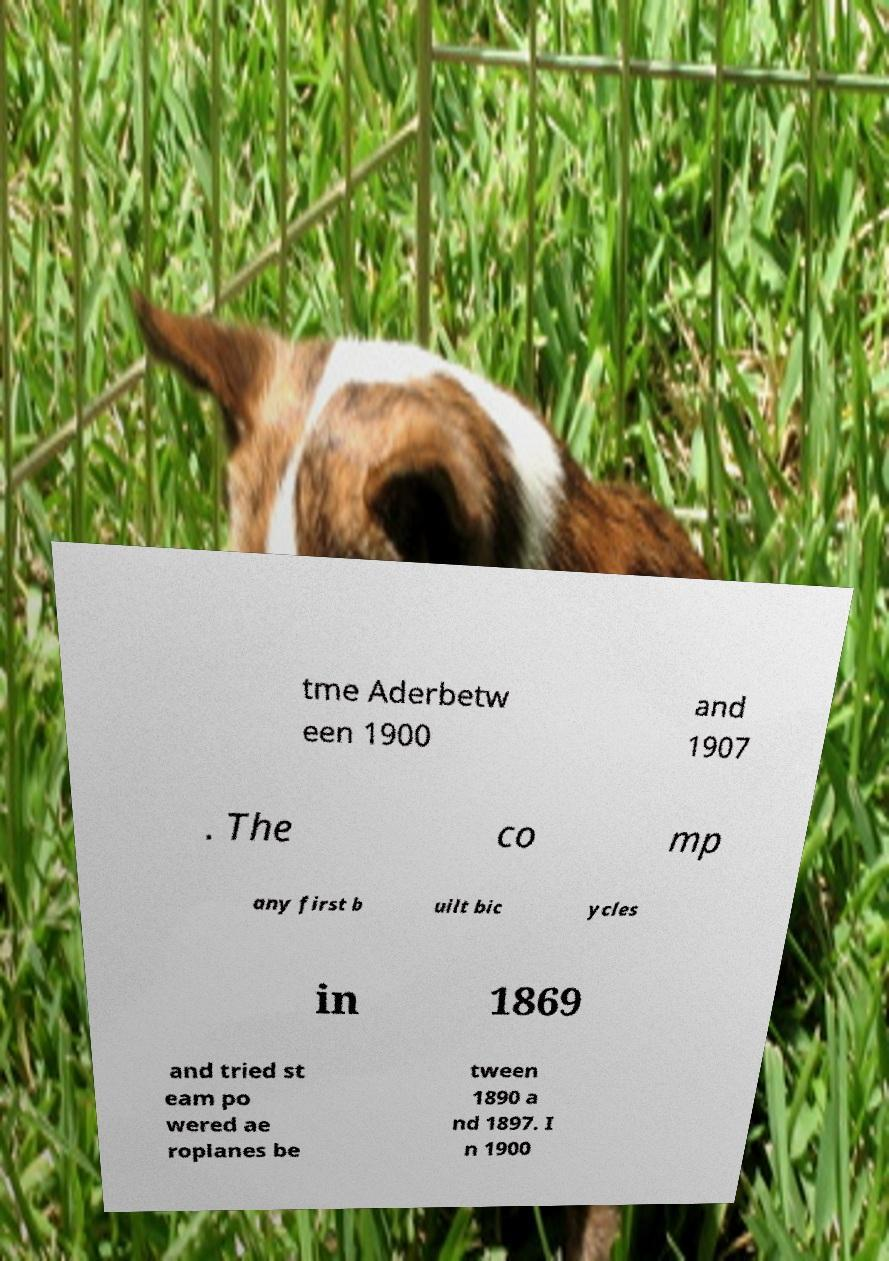I need the written content from this picture converted into text. Can you do that? tme Aderbetw een 1900 and 1907 . The co mp any first b uilt bic ycles in 1869 and tried st eam po wered ae roplanes be tween 1890 a nd 1897. I n 1900 